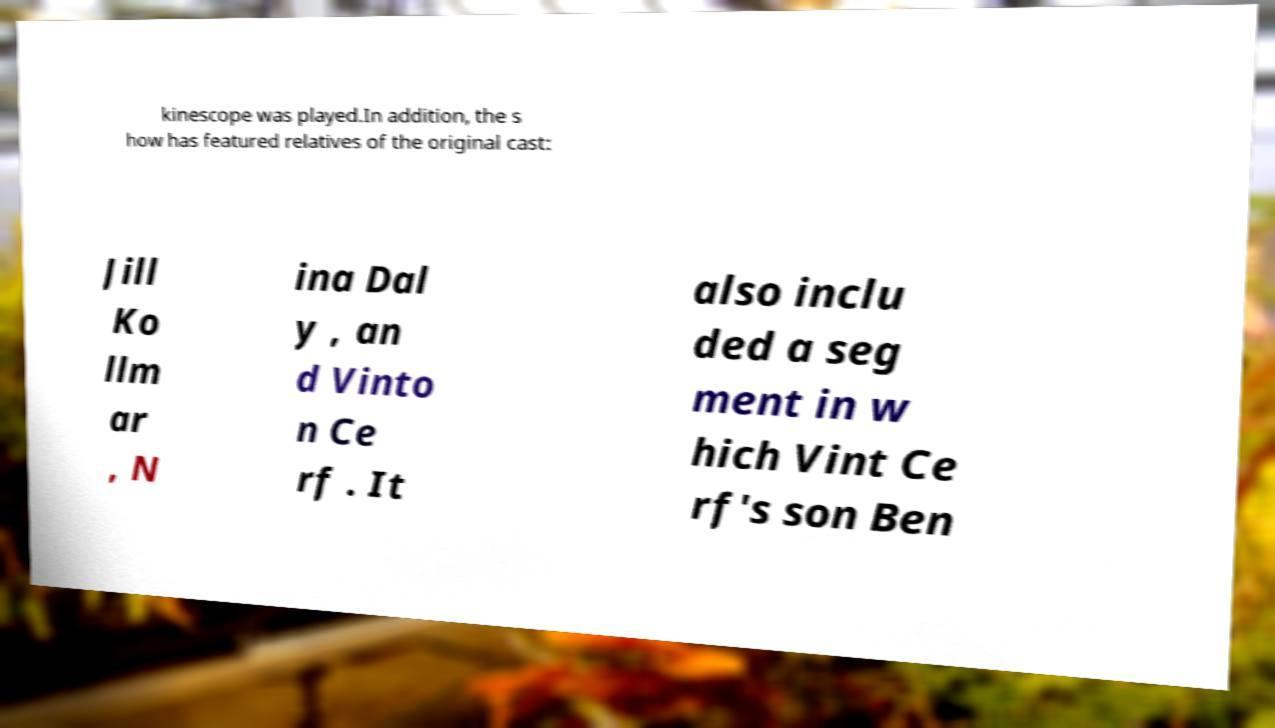For documentation purposes, I need the text within this image transcribed. Could you provide that? kinescope was played.In addition, the s how has featured relatives of the original cast: Jill Ko llm ar , N ina Dal y , an d Vinto n Ce rf . It also inclu ded a seg ment in w hich Vint Ce rf's son Ben 